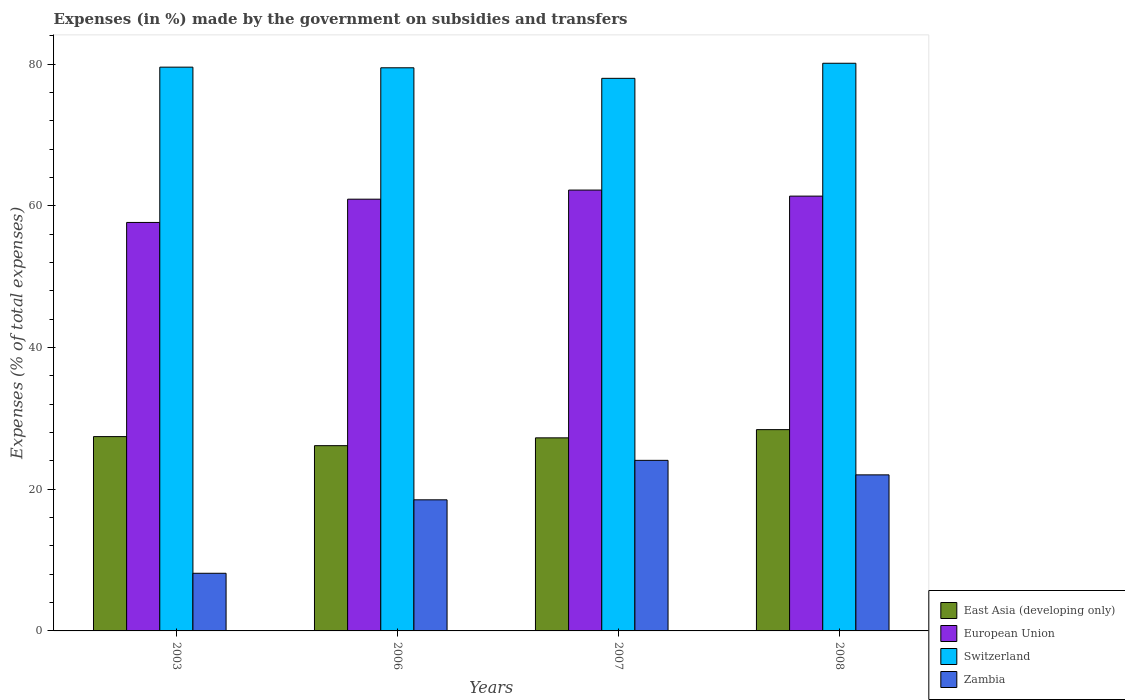Are the number of bars per tick equal to the number of legend labels?
Offer a very short reply. Yes. How many bars are there on the 2nd tick from the right?
Provide a succinct answer. 4. What is the percentage of expenses made by the government on subsidies and transfers in European Union in 2006?
Provide a succinct answer. 60.93. Across all years, what is the maximum percentage of expenses made by the government on subsidies and transfers in Switzerland?
Your answer should be very brief. 80.12. Across all years, what is the minimum percentage of expenses made by the government on subsidies and transfers in European Union?
Your answer should be compact. 57.65. In which year was the percentage of expenses made by the government on subsidies and transfers in Zambia maximum?
Offer a terse response. 2007. In which year was the percentage of expenses made by the government on subsidies and transfers in Switzerland minimum?
Provide a succinct answer. 2007. What is the total percentage of expenses made by the government on subsidies and transfers in East Asia (developing only) in the graph?
Offer a terse response. 109.23. What is the difference between the percentage of expenses made by the government on subsidies and transfers in Zambia in 2003 and that in 2007?
Ensure brevity in your answer.  -15.94. What is the difference between the percentage of expenses made by the government on subsidies and transfers in Switzerland in 2007 and the percentage of expenses made by the government on subsidies and transfers in European Union in 2003?
Make the answer very short. 20.34. What is the average percentage of expenses made by the government on subsidies and transfers in East Asia (developing only) per year?
Keep it short and to the point. 27.31. In the year 2008, what is the difference between the percentage of expenses made by the government on subsidies and transfers in Switzerland and percentage of expenses made by the government on subsidies and transfers in East Asia (developing only)?
Offer a terse response. 51.71. In how many years, is the percentage of expenses made by the government on subsidies and transfers in Zambia greater than 36 %?
Offer a terse response. 0. What is the ratio of the percentage of expenses made by the government on subsidies and transfers in Switzerland in 2003 to that in 2008?
Give a very brief answer. 0.99. Is the difference between the percentage of expenses made by the government on subsidies and transfers in Switzerland in 2006 and 2008 greater than the difference between the percentage of expenses made by the government on subsidies and transfers in East Asia (developing only) in 2006 and 2008?
Ensure brevity in your answer.  Yes. What is the difference between the highest and the second highest percentage of expenses made by the government on subsidies and transfers in Switzerland?
Give a very brief answer. 0.55. What is the difference between the highest and the lowest percentage of expenses made by the government on subsidies and transfers in European Union?
Give a very brief answer. 4.57. Is the sum of the percentage of expenses made by the government on subsidies and transfers in European Union in 2007 and 2008 greater than the maximum percentage of expenses made by the government on subsidies and transfers in Switzerland across all years?
Offer a very short reply. Yes. Is it the case that in every year, the sum of the percentage of expenses made by the government on subsidies and transfers in European Union and percentage of expenses made by the government on subsidies and transfers in Switzerland is greater than the sum of percentage of expenses made by the government on subsidies and transfers in East Asia (developing only) and percentage of expenses made by the government on subsidies and transfers in Zambia?
Your answer should be very brief. Yes. What does the 3rd bar from the left in 2007 represents?
Your answer should be very brief. Switzerland. What does the 4th bar from the right in 2006 represents?
Keep it short and to the point. East Asia (developing only). Are all the bars in the graph horizontal?
Make the answer very short. No. How many years are there in the graph?
Your response must be concise. 4. What is the difference between two consecutive major ticks on the Y-axis?
Make the answer very short. 20. Are the values on the major ticks of Y-axis written in scientific E-notation?
Ensure brevity in your answer.  No. Where does the legend appear in the graph?
Ensure brevity in your answer.  Bottom right. How many legend labels are there?
Keep it short and to the point. 4. What is the title of the graph?
Make the answer very short. Expenses (in %) made by the government on subsidies and transfers. What is the label or title of the X-axis?
Provide a short and direct response. Years. What is the label or title of the Y-axis?
Offer a terse response. Expenses (% of total expenses). What is the Expenses (% of total expenses) in East Asia (developing only) in 2003?
Make the answer very short. 27.42. What is the Expenses (% of total expenses) of European Union in 2003?
Your answer should be very brief. 57.65. What is the Expenses (% of total expenses) of Switzerland in 2003?
Offer a very short reply. 79.57. What is the Expenses (% of total expenses) in Zambia in 2003?
Provide a short and direct response. 8.14. What is the Expenses (% of total expenses) of East Asia (developing only) in 2006?
Offer a terse response. 26.15. What is the Expenses (% of total expenses) in European Union in 2006?
Your answer should be compact. 60.93. What is the Expenses (% of total expenses) of Switzerland in 2006?
Your response must be concise. 79.48. What is the Expenses (% of total expenses) of Zambia in 2006?
Your answer should be compact. 18.5. What is the Expenses (% of total expenses) in East Asia (developing only) in 2007?
Ensure brevity in your answer.  27.25. What is the Expenses (% of total expenses) of European Union in 2007?
Provide a short and direct response. 62.22. What is the Expenses (% of total expenses) in Switzerland in 2007?
Your answer should be compact. 77.99. What is the Expenses (% of total expenses) in Zambia in 2007?
Provide a short and direct response. 24.07. What is the Expenses (% of total expenses) in East Asia (developing only) in 2008?
Offer a terse response. 28.41. What is the Expenses (% of total expenses) of European Union in 2008?
Your answer should be very brief. 61.36. What is the Expenses (% of total expenses) in Switzerland in 2008?
Provide a short and direct response. 80.12. What is the Expenses (% of total expenses) of Zambia in 2008?
Your answer should be very brief. 22.02. Across all years, what is the maximum Expenses (% of total expenses) in East Asia (developing only)?
Your response must be concise. 28.41. Across all years, what is the maximum Expenses (% of total expenses) of European Union?
Offer a terse response. 62.22. Across all years, what is the maximum Expenses (% of total expenses) of Switzerland?
Your response must be concise. 80.12. Across all years, what is the maximum Expenses (% of total expenses) in Zambia?
Your response must be concise. 24.07. Across all years, what is the minimum Expenses (% of total expenses) in East Asia (developing only)?
Give a very brief answer. 26.15. Across all years, what is the minimum Expenses (% of total expenses) of European Union?
Your answer should be very brief. 57.65. Across all years, what is the minimum Expenses (% of total expenses) in Switzerland?
Provide a succinct answer. 77.99. Across all years, what is the minimum Expenses (% of total expenses) in Zambia?
Offer a very short reply. 8.14. What is the total Expenses (% of total expenses) of East Asia (developing only) in the graph?
Give a very brief answer. 109.23. What is the total Expenses (% of total expenses) in European Union in the graph?
Your answer should be very brief. 242.16. What is the total Expenses (% of total expenses) of Switzerland in the graph?
Give a very brief answer. 317.14. What is the total Expenses (% of total expenses) of Zambia in the graph?
Give a very brief answer. 72.74. What is the difference between the Expenses (% of total expenses) of East Asia (developing only) in 2003 and that in 2006?
Your answer should be compact. 1.28. What is the difference between the Expenses (% of total expenses) in European Union in 2003 and that in 2006?
Your answer should be very brief. -3.28. What is the difference between the Expenses (% of total expenses) in Switzerland in 2003 and that in 2006?
Your answer should be compact. 0.09. What is the difference between the Expenses (% of total expenses) in Zambia in 2003 and that in 2006?
Make the answer very short. -10.36. What is the difference between the Expenses (% of total expenses) of East Asia (developing only) in 2003 and that in 2007?
Offer a very short reply. 0.18. What is the difference between the Expenses (% of total expenses) in European Union in 2003 and that in 2007?
Offer a very short reply. -4.57. What is the difference between the Expenses (% of total expenses) of Switzerland in 2003 and that in 2007?
Provide a short and direct response. 1.58. What is the difference between the Expenses (% of total expenses) in Zambia in 2003 and that in 2007?
Your answer should be very brief. -15.94. What is the difference between the Expenses (% of total expenses) in East Asia (developing only) in 2003 and that in 2008?
Make the answer very short. -0.98. What is the difference between the Expenses (% of total expenses) in European Union in 2003 and that in 2008?
Your answer should be compact. -3.72. What is the difference between the Expenses (% of total expenses) in Switzerland in 2003 and that in 2008?
Keep it short and to the point. -0.55. What is the difference between the Expenses (% of total expenses) of Zambia in 2003 and that in 2008?
Give a very brief answer. -13.89. What is the difference between the Expenses (% of total expenses) of East Asia (developing only) in 2006 and that in 2007?
Provide a short and direct response. -1.1. What is the difference between the Expenses (% of total expenses) in European Union in 2006 and that in 2007?
Provide a succinct answer. -1.29. What is the difference between the Expenses (% of total expenses) in Switzerland in 2006 and that in 2007?
Make the answer very short. 1.49. What is the difference between the Expenses (% of total expenses) in Zambia in 2006 and that in 2007?
Ensure brevity in your answer.  -5.57. What is the difference between the Expenses (% of total expenses) in East Asia (developing only) in 2006 and that in 2008?
Ensure brevity in your answer.  -2.26. What is the difference between the Expenses (% of total expenses) of European Union in 2006 and that in 2008?
Make the answer very short. -0.43. What is the difference between the Expenses (% of total expenses) in Switzerland in 2006 and that in 2008?
Provide a succinct answer. -0.64. What is the difference between the Expenses (% of total expenses) of Zambia in 2006 and that in 2008?
Provide a short and direct response. -3.52. What is the difference between the Expenses (% of total expenses) in East Asia (developing only) in 2007 and that in 2008?
Offer a very short reply. -1.16. What is the difference between the Expenses (% of total expenses) in European Union in 2007 and that in 2008?
Keep it short and to the point. 0.85. What is the difference between the Expenses (% of total expenses) in Switzerland in 2007 and that in 2008?
Offer a very short reply. -2.13. What is the difference between the Expenses (% of total expenses) of Zambia in 2007 and that in 2008?
Provide a short and direct response. 2.05. What is the difference between the Expenses (% of total expenses) in East Asia (developing only) in 2003 and the Expenses (% of total expenses) in European Union in 2006?
Ensure brevity in your answer.  -33.51. What is the difference between the Expenses (% of total expenses) in East Asia (developing only) in 2003 and the Expenses (% of total expenses) in Switzerland in 2006?
Your response must be concise. -52.05. What is the difference between the Expenses (% of total expenses) of East Asia (developing only) in 2003 and the Expenses (% of total expenses) of Zambia in 2006?
Make the answer very short. 8.92. What is the difference between the Expenses (% of total expenses) of European Union in 2003 and the Expenses (% of total expenses) of Switzerland in 2006?
Provide a short and direct response. -21.83. What is the difference between the Expenses (% of total expenses) in European Union in 2003 and the Expenses (% of total expenses) in Zambia in 2006?
Your answer should be compact. 39.15. What is the difference between the Expenses (% of total expenses) in Switzerland in 2003 and the Expenses (% of total expenses) in Zambia in 2006?
Offer a terse response. 61.06. What is the difference between the Expenses (% of total expenses) in East Asia (developing only) in 2003 and the Expenses (% of total expenses) in European Union in 2007?
Offer a terse response. -34.79. What is the difference between the Expenses (% of total expenses) in East Asia (developing only) in 2003 and the Expenses (% of total expenses) in Switzerland in 2007?
Make the answer very short. -50.56. What is the difference between the Expenses (% of total expenses) of East Asia (developing only) in 2003 and the Expenses (% of total expenses) of Zambia in 2007?
Your answer should be very brief. 3.35. What is the difference between the Expenses (% of total expenses) of European Union in 2003 and the Expenses (% of total expenses) of Switzerland in 2007?
Keep it short and to the point. -20.34. What is the difference between the Expenses (% of total expenses) of European Union in 2003 and the Expenses (% of total expenses) of Zambia in 2007?
Your answer should be compact. 33.57. What is the difference between the Expenses (% of total expenses) in Switzerland in 2003 and the Expenses (% of total expenses) in Zambia in 2007?
Provide a short and direct response. 55.49. What is the difference between the Expenses (% of total expenses) in East Asia (developing only) in 2003 and the Expenses (% of total expenses) in European Union in 2008?
Ensure brevity in your answer.  -33.94. What is the difference between the Expenses (% of total expenses) in East Asia (developing only) in 2003 and the Expenses (% of total expenses) in Switzerland in 2008?
Give a very brief answer. -52.69. What is the difference between the Expenses (% of total expenses) of East Asia (developing only) in 2003 and the Expenses (% of total expenses) of Zambia in 2008?
Provide a succinct answer. 5.4. What is the difference between the Expenses (% of total expenses) of European Union in 2003 and the Expenses (% of total expenses) of Switzerland in 2008?
Offer a very short reply. -22.47. What is the difference between the Expenses (% of total expenses) in European Union in 2003 and the Expenses (% of total expenses) in Zambia in 2008?
Give a very brief answer. 35.62. What is the difference between the Expenses (% of total expenses) in Switzerland in 2003 and the Expenses (% of total expenses) in Zambia in 2008?
Your response must be concise. 57.54. What is the difference between the Expenses (% of total expenses) in East Asia (developing only) in 2006 and the Expenses (% of total expenses) in European Union in 2007?
Your response must be concise. -36.07. What is the difference between the Expenses (% of total expenses) of East Asia (developing only) in 2006 and the Expenses (% of total expenses) of Switzerland in 2007?
Offer a terse response. -51.84. What is the difference between the Expenses (% of total expenses) of East Asia (developing only) in 2006 and the Expenses (% of total expenses) of Zambia in 2007?
Give a very brief answer. 2.07. What is the difference between the Expenses (% of total expenses) of European Union in 2006 and the Expenses (% of total expenses) of Switzerland in 2007?
Make the answer very short. -17.06. What is the difference between the Expenses (% of total expenses) in European Union in 2006 and the Expenses (% of total expenses) in Zambia in 2007?
Keep it short and to the point. 36.86. What is the difference between the Expenses (% of total expenses) of Switzerland in 2006 and the Expenses (% of total expenses) of Zambia in 2007?
Provide a short and direct response. 55.4. What is the difference between the Expenses (% of total expenses) of East Asia (developing only) in 2006 and the Expenses (% of total expenses) of European Union in 2008?
Provide a succinct answer. -35.22. What is the difference between the Expenses (% of total expenses) of East Asia (developing only) in 2006 and the Expenses (% of total expenses) of Switzerland in 2008?
Provide a short and direct response. -53.97. What is the difference between the Expenses (% of total expenses) in East Asia (developing only) in 2006 and the Expenses (% of total expenses) in Zambia in 2008?
Offer a very short reply. 4.12. What is the difference between the Expenses (% of total expenses) in European Union in 2006 and the Expenses (% of total expenses) in Switzerland in 2008?
Offer a terse response. -19.18. What is the difference between the Expenses (% of total expenses) of European Union in 2006 and the Expenses (% of total expenses) of Zambia in 2008?
Give a very brief answer. 38.91. What is the difference between the Expenses (% of total expenses) of Switzerland in 2006 and the Expenses (% of total expenses) of Zambia in 2008?
Keep it short and to the point. 57.45. What is the difference between the Expenses (% of total expenses) of East Asia (developing only) in 2007 and the Expenses (% of total expenses) of European Union in 2008?
Make the answer very short. -34.12. What is the difference between the Expenses (% of total expenses) in East Asia (developing only) in 2007 and the Expenses (% of total expenses) in Switzerland in 2008?
Provide a short and direct response. -52.87. What is the difference between the Expenses (% of total expenses) of East Asia (developing only) in 2007 and the Expenses (% of total expenses) of Zambia in 2008?
Your answer should be compact. 5.22. What is the difference between the Expenses (% of total expenses) in European Union in 2007 and the Expenses (% of total expenses) in Switzerland in 2008?
Provide a short and direct response. -17.9. What is the difference between the Expenses (% of total expenses) of European Union in 2007 and the Expenses (% of total expenses) of Zambia in 2008?
Give a very brief answer. 40.19. What is the difference between the Expenses (% of total expenses) in Switzerland in 2007 and the Expenses (% of total expenses) in Zambia in 2008?
Provide a succinct answer. 55.96. What is the average Expenses (% of total expenses) in East Asia (developing only) per year?
Offer a terse response. 27.31. What is the average Expenses (% of total expenses) of European Union per year?
Ensure brevity in your answer.  60.54. What is the average Expenses (% of total expenses) in Switzerland per year?
Give a very brief answer. 79.29. What is the average Expenses (% of total expenses) of Zambia per year?
Provide a short and direct response. 18.18. In the year 2003, what is the difference between the Expenses (% of total expenses) in East Asia (developing only) and Expenses (% of total expenses) in European Union?
Your response must be concise. -30.22. In the year 2003, what is the difference between the Expenses (% of total expenses) in East Asia (developing only) and Expenses (% of total expenses) in Switzerland?
Keep it short and to the point. -52.14. In the year 2003, what is the difference between the Expenses (% of total expenses) of East Asia (developing only) and Expenses (% of total expenses) of Zambia?
Ensure brevity in your answer.  19.29. In the year 2003, what is the difference between the Expenses (% of total expenses) of European Union and Expenses (% of total expenses) of Switzerland?
Your answer should be very brief. -21.92. In the year 2003, what is the difference between the Expenses (% of total expenses) in European Union and Expenses (% of total expenses) in Zambia?
Keep it short and to the point. 49.51. In the year 2003, what is the difference between the Expenses (% of total expenses) in Switzerland and Expenses (% of total expenses) in Zambia?
Give a very brief answer. 71.43. In the year 2006, what is the difference between the Expenses (% of total expenses) in East Asia (developing only) and Expenses (% of total expenses) in European Union?
Give a very brief answer. -34.78. In the year 2006, what is the difference between the Expenses (% of total expenses) of East Asia (developing only) and Expenses (% of total expenses) of Switzerland?
Give a very brief answer. -53.33. In the year 2006, what is the difference between the Expenses (% of total expenses) of East Asia (developing only) and Expenses (% of total expenses) of Zambia?
Your answer should be compact. 7.64. In the year 2006, what is the difference between the Expenses (% of total expenses) in European Union and Expenses (% of total expenses) in Switzerland?
Make the answer very short. -18.54. In the year 2006, what is the difference between the Expenses (% of total expenses) in European Union and Expenses (% of total expenses) in Zambia?
Ensure brevity in your answer.  42.43. In the year 2006, what is the difference between the Expenses (% of total expenses) in Switzerland and Expenses (% of total expenses) in Zambia?
Offer a very short reply. 60.97. In the year 2007, what is the difference between the Expenses (% of total expenses) of East Asia (developing only) and Expenses (% of total expenses) of European Union?
Make the answer very short. -34.97. In the year 2007, what is the difference between the Expenses (% of total expenses) of East Asia (developing only) and Expenses (% of total expenses) of Switzerland?
Your answer should be compact. -50.74. In the year 2007, what is the difference between the Expenses (% of total expenses) in East Asia (developing only) and Expenses (% of total expenses) in Zambia?
Your answer should be very brief. 3.17. In the year 2007, what is the difference between the Expenses (% of total expenses) of European Union and Expenses (% of total expenses) of Switzerland?
Provide a succinct answer. -15.77. In the year 2007, what is the difference between the Expenses (% of total expenses) of European Union and Expenses (% of total expenses) of Zambia?
Offer a very short reply. 38.14. In the year 2007, what is the difference between the Expenses (% of total expenses) in Switzerland and Expenses (% of total expenses) in Zambia?
Make the answer very short. 53.91. In the year 2008, what is the difference between the Expenses (% of total expenses) in East Asia (developing only) and Expenses (% of total expenses) in European Union?
Offer a terse response. -32.96. In the year 2008, what is the difference between the Expenses (% of total expenses) in East Asia (developing only) and Expenses (% of total expenses) in Switzerland?
Provide a succinct answer. -51.71. In the year 2008, what is the difference between the Expenses (% of total expenses) of East Asia (developing only) and Expenses (% of total expenses) of Zambia?
Your response must be concise. 6.38. In the year 2008, what is the difference between the Expenses (% of total expenses) in European Union and Expenses (% of total expenses) in Switzerland?
Provide a short and direct response. -18.75. In the year 2008, what is the difference between the Expenses (% of total expenses) in European Union and Expenses (% of total expenses) in Zambia?
Ensure brevity in your answer.  39.34. In the year 2008, what is the difference between the Expenses (% of total expenses) in Switzerland and Expenses (% of total expenses) in Zambia?
Ensure brevity in your answer.  58.09. What is the ratio of the Expenses (% of total expenses) of East Asia (developing only) in 2003 to that in 2006?
Give a very brief answer. 1.05. What is the ratio of the Expenses (% of total expenses) of European Union in 2003 to that in 2006?
Make the answer very short. 0.95. What is the ratio of the Expenses (% of total expenses) in Switzerland in 2003 to that in 2006?
Provide a short and direct response. 1. What is the ratio of the Expenses (% of total expenses) in Zambia in 2003 to that in 2006?
Ensure brevity in your answer.  0.44. What is the ratio of the Expenses (% of total expenses) in European Union in 2003 to that in 2007?
Make the answer very short. 0.93. What is the ratio of the Expenses (% of total expenses) of Switzerland in 2003 to that in 2007?
Ensure brevity in your answer.  1.02. What is the ratio of the Expenses (% of total expenses) of Zambia in 2003 to that in 2007?
Ensure brevity in your answer.  0.34. What is the ratio of the Expenses (% of total expenses) of East Asia (developing only) in 2003 to that in 2008?
Offer a terse response. 0.97. What is the ratio of the Expenses (% of total expenses) of European Union in 2003 to that in 2008?
Give a very brief answer. 0.94. What is the ratio of the Expenses (% of total expenses) of Switzerland in 2003 to that in 2008?
Give a very brief answer. 0.99. What is the ratio of the Expenses (% of total expenses) of Zambia in 2003 to that in 2008?
Provide a succinct answer. 0.37. What is the ratio of the Expenses (% of total expenses) in East Asia (developing only) in 2006 to that in 2007?
Make the answer very short. 0.96. What is the ratio of the Expenses (% of total expenses) of European Union in 2006 to that in 2007?
Provide a succinct answer. 0.98. What is the ratio of the Expenses (% of total expenses) in Switzerland in 2006 to that in 2007?
Offer a terse response. 1.02. What is the ratio of the Expenses (% of total expenses) of Zambia in 2006 to that in 2007?
Provide a succinct answer. 0.77. What is the ratio of the Expenses (% of total expenses) of East Asia (developing only) in 2006 to that in 2008?
Keep it short and to the point. 0.92. What is the ratio of the Expenses (% of total expenses) in European Union in 2006 to that in 2008?
Give a very brief answer. 0.99. What is the ratio of the Expenses (% of total expenses) in Zambia in 2006 to that in 2008?
Offer a very short reply. 0.84. What is the ratio of the Expenses (% of total expenses) in East Asia (developing only) in 2007 to that in 2008?
Your response must be concise. 0.96. What is the ratio of the Expenses (% of total expenses) in European Union in 2007 to that in 2008?
Your answer should be very brief. 1.01. What is the ratio of the Expenses (% of total expenses) in Switzerland in 2007 to that in 2008?
Keep it short and to the point. 0.97. What is the ratio of the Expenses (% of total expenses) in Zambia in 2007 to that in 2008?
Your response must be concise. 1.09. What is the difference between the highest and the second highest Expenses (% of total expenses) of East Asia (developing only)?
Provide a succinct answer. 0.98. What is the difference between the highest and the second highest Expenses (% of total expenses) in European Union?
Provide a succinct answer. 0.85. What is the difference between the highest and the second highest Expenses (% of total expenses) in Switzerland?
Ensure brevity in your answer.  0.55. What is the difference between the highest and the second highest Expenses (% of total expenses) of Zambia?
Your response must be concise. 2.05. What is the difference between the highest and the lowest Expenses (% of total expenses) in East Asia (developing only)?
Offer a terse response. 2.26. What is the difference between the highest and the lowest Expenses (% of total expenses) of European Union?
Offer a terse response. 4.57. What is the difference between the highest and the lowest Expenses (% of total expenses) of Switzerland?
Make the answer very short. 2.13. What is the difference between the highest and the lowest Expenses (% of total expenses) of Zambia?
Provide a short and direct response. 15.94. 